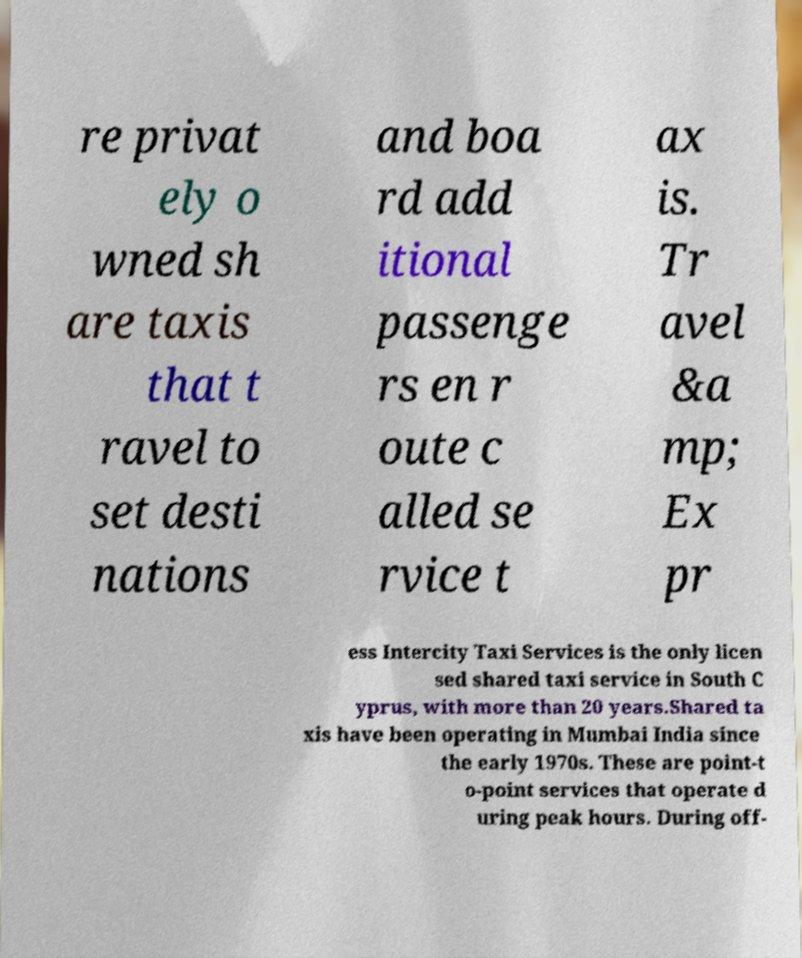Could you extract and type out the text from this image? re privat ely o wned sh are taxis that t ravel to set desti nations and boa rd add itional passenge rs en r oute c alled se rvice t ax is. Tr avel &a mp; Ex pr ess Intercity Taxi Services is the only licen sed shared taxi service in South C yprus, with more than 20 years.Shared ta xis have been operating in Mumbai India since the early 1970s. These are point-t o-point services that operate d uring peak hours. During off- 